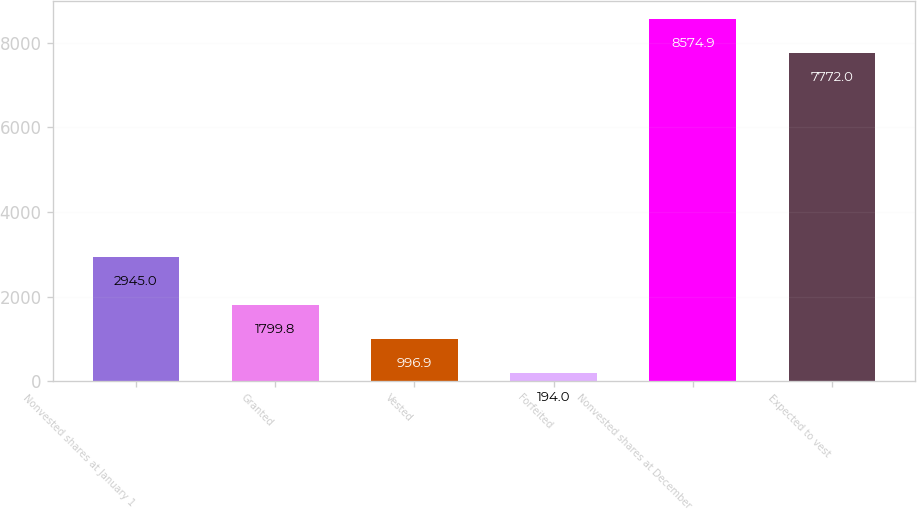Convert chart. <chart><loc_0><loc_0><loc_500><loc_500><bar_chart><fcel>Nonvested shares at January 1<fcel>Granted<fcel>Vested<fcel>Forfeited<fcel>Nonvested shares at December<fcel>Expected to vest<nl><fcel>2945<fcel>1799.8<fcel>996.9<fcel>194<fcel>8574.9<fcel>7772<nl></chart> 